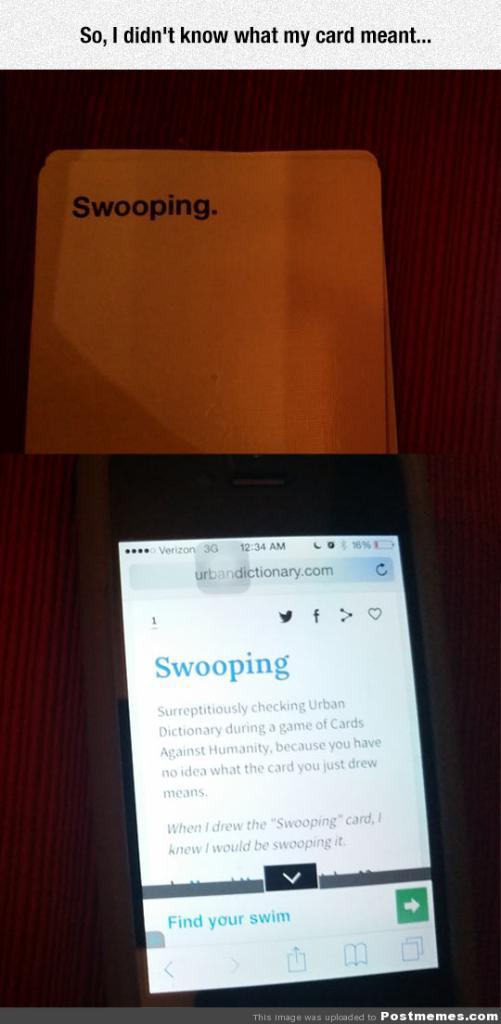How would you summarize this image in a sentence or two? In this picture we can see small mobile screen on which "Scooping" is written. 